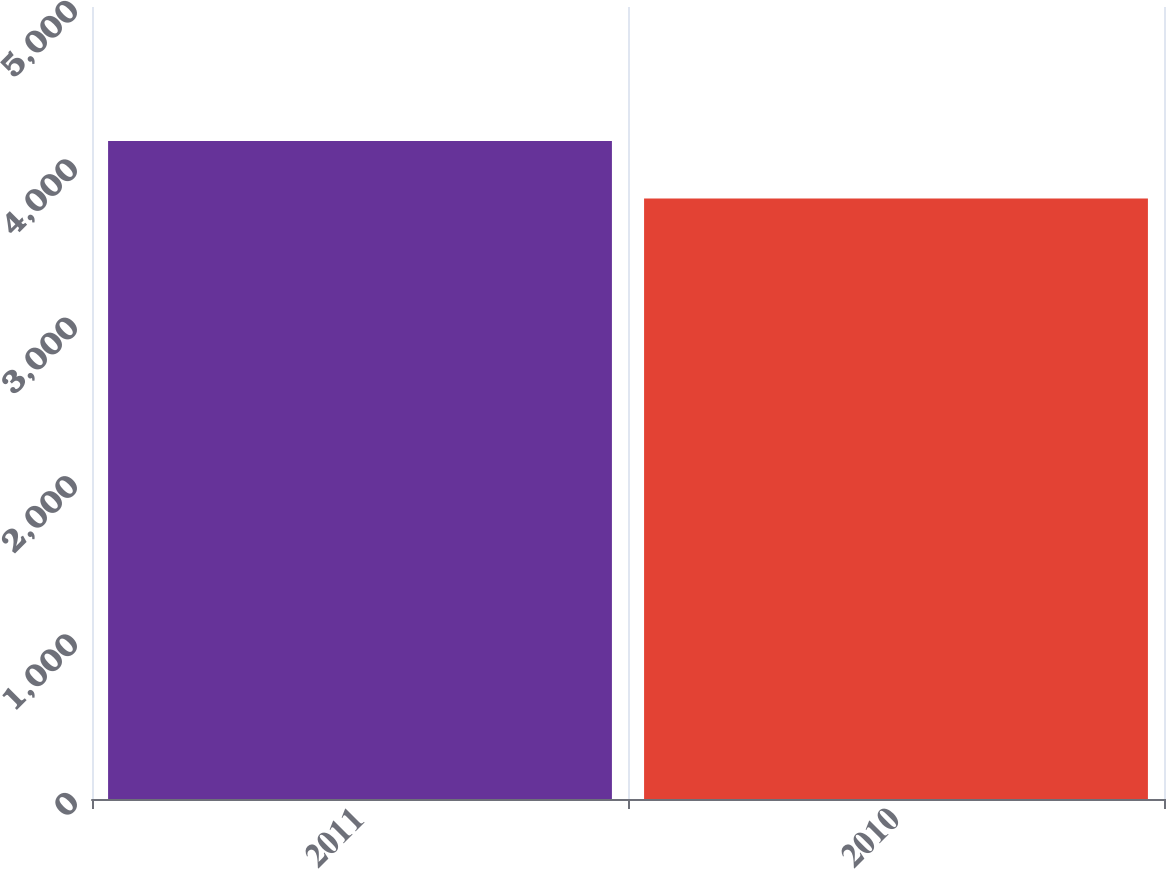<chart> <loc_0><loc_0><loc_500><loc_500><bar_chart><fcel>2011<fcel>2010<nl><fcel>4154<fcel>3791<nl></chart> 